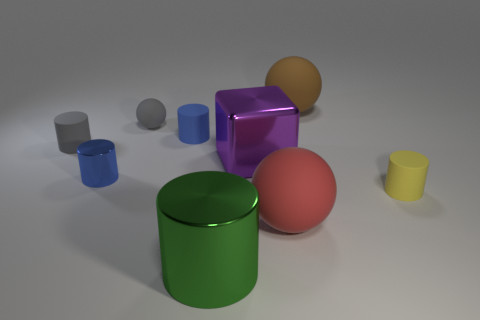Subtract all green metal cylinders. How many cylinders are left? 4 Subtract all gray cylinders. How many cylinders are left? 4 Subtract all purple cylinders. Subtract all yellow spheres. How many cylinders are left? 5 Add 1 large green things. How many objects exist? 10 Subtract all cubes. How many objects are left? 8 Subtract 0 gray blocks. How many objects are left? 9 Subtract all purple balls. Subtract all blue matte things. How many objects are left? 8 Add 7 tiny gray rubber balls. How many tiny gray rubber balls are left? 8 Add 8 purple metallic things. How many purple metallic things exist? 9 